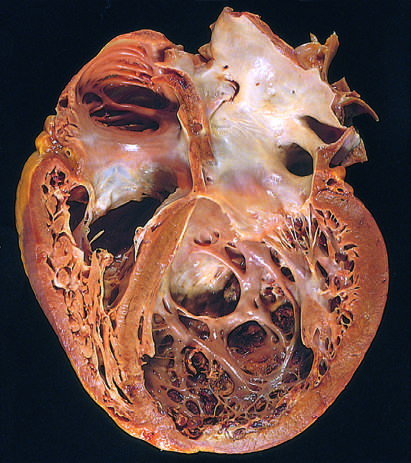what is evident?
Answer the question using a single word or phrase. Four-chamber dilation and hypertrophy 